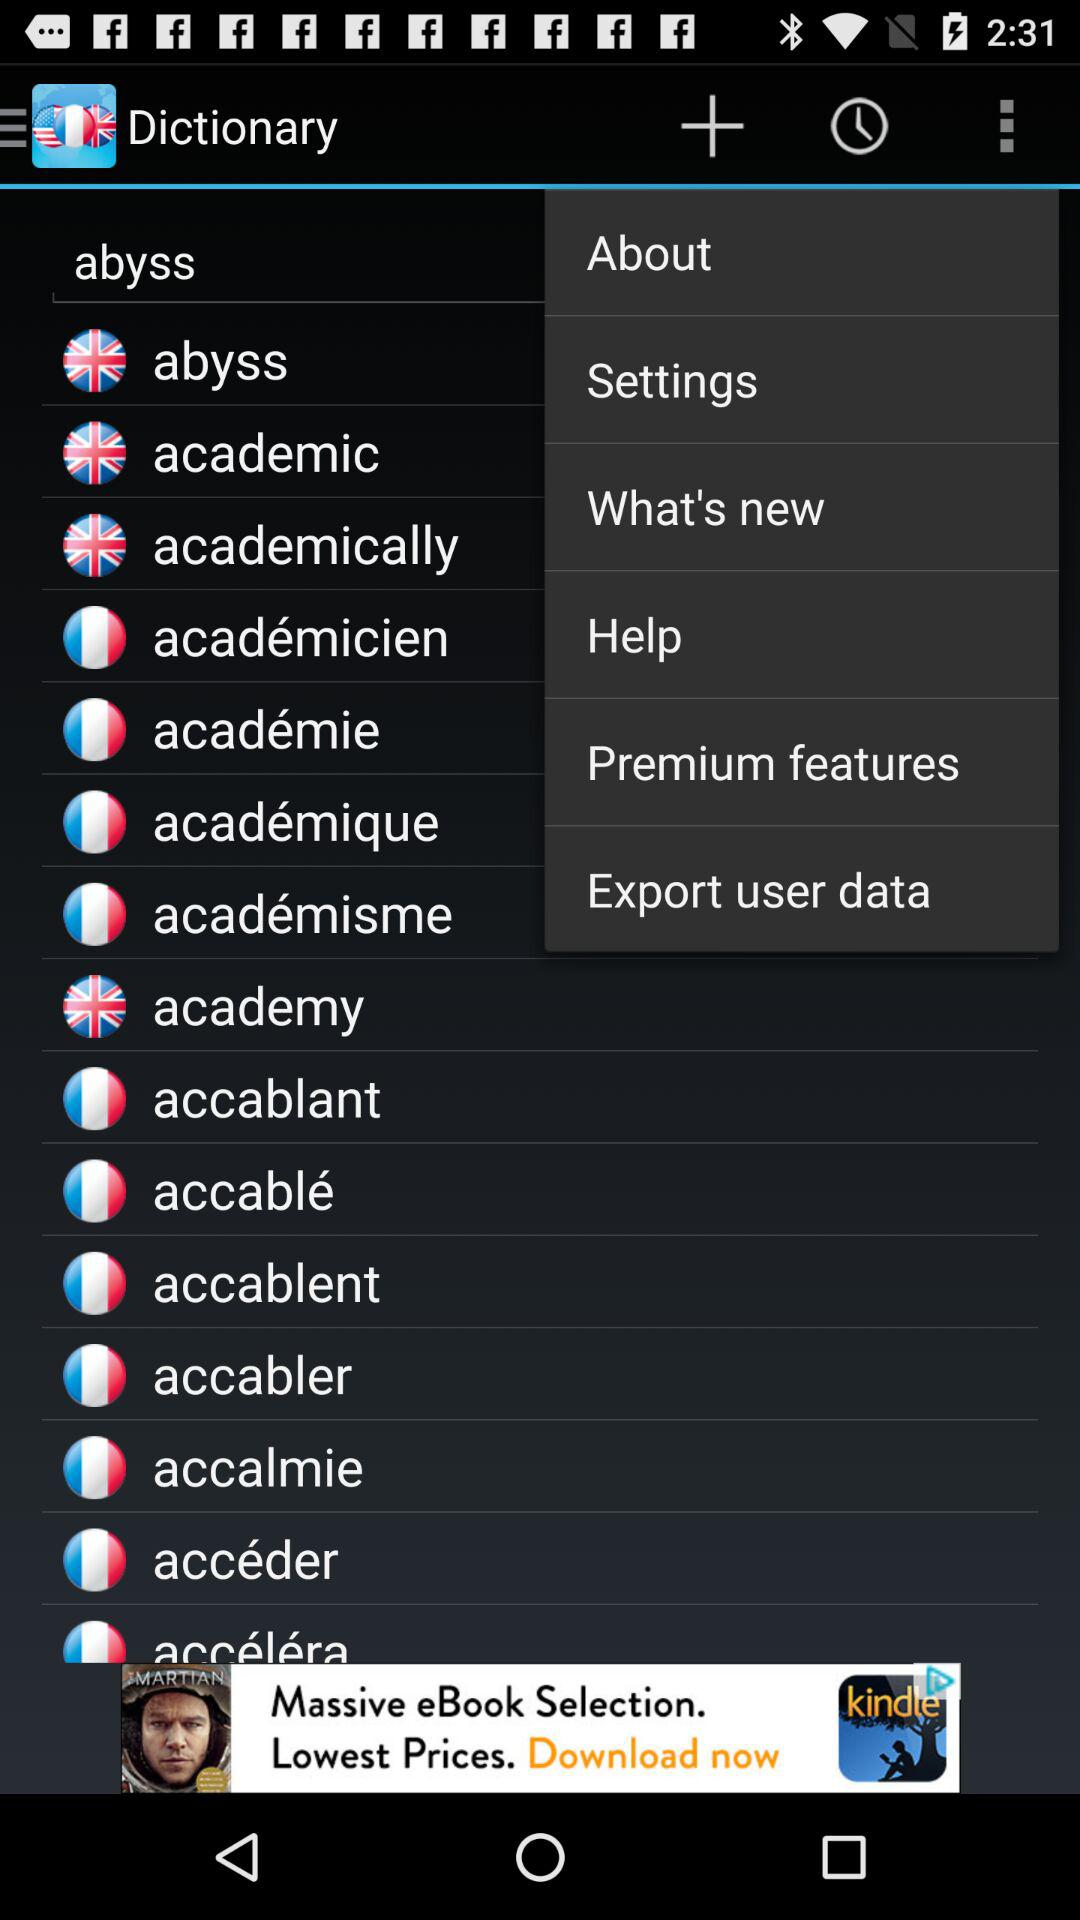What is the name of the application? The name of the application is "Dictionary". 